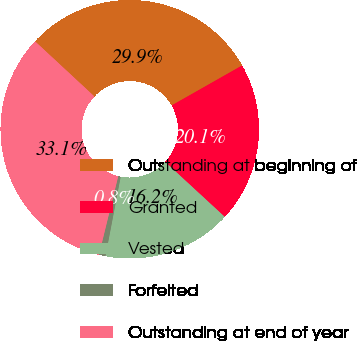<chart> <loc_0><loc_0><loc_500><loc_500><pie_chart><fcel>Outstanding at beginning of<fcel>Granted<fcel>Vested<fcel>Forfeited<fcel>Outstanding at end of year<nl><fcel>29.87%<fcel>20.07%<fcel>16.15%<fcel>0.82%<fcel>33.08%<nl></chart> 